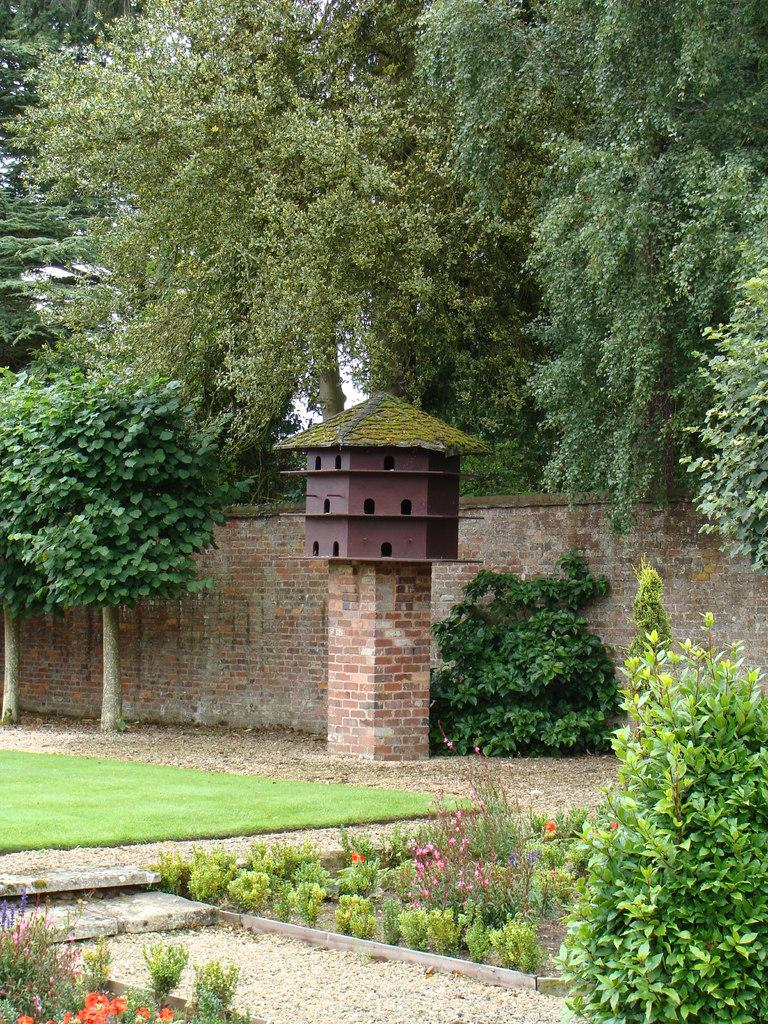What type of vegetation can be seen in the image? There are many plants, grass, and trees in the image. What is on the ground in the image? There is grass on the ground in the image. What can be seen in the background of the image? There is a brick wall in the background of the image. What structure is present for birds in the image? There is a bird house on a stand in the image. What material is the bird house stand made of? The bird house stand is made of bricks. How many flowers are present in the sand in the image? There are no flowers or sand present in the image; it features plants, grass, trees, a brick wall, and a bird house on a brick stand. 